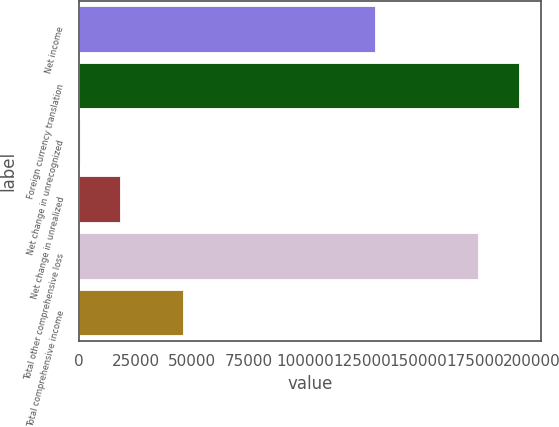<chart> <loc_0><loc_0><loc_500><loc_500><bar_chart><fcel>Net income<fcel>Foreign currency translation<fcel>Net change in unrecognized<fcel>Net change in unrealized<fcel>Total other comprehensive loss<fcel>Total comprehensive income<nl><fcel>130647<fcel>194213<fcel>389<fcel>18141.2<fcel>176461<fcel>45814<nl></chart> 